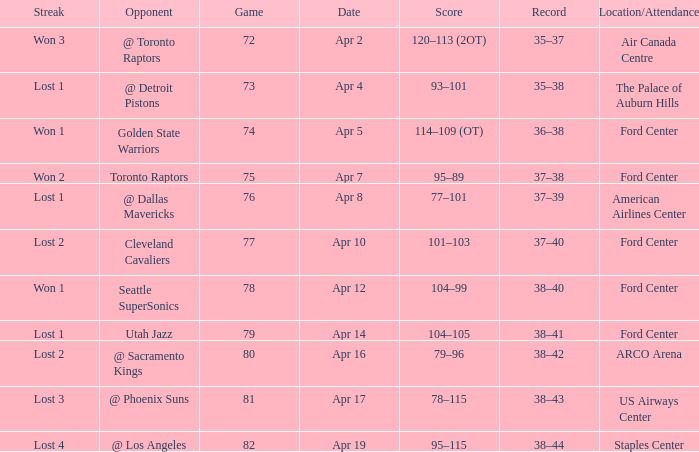What was the location when the opponent was Seattle Supersonics? Ford Center. 